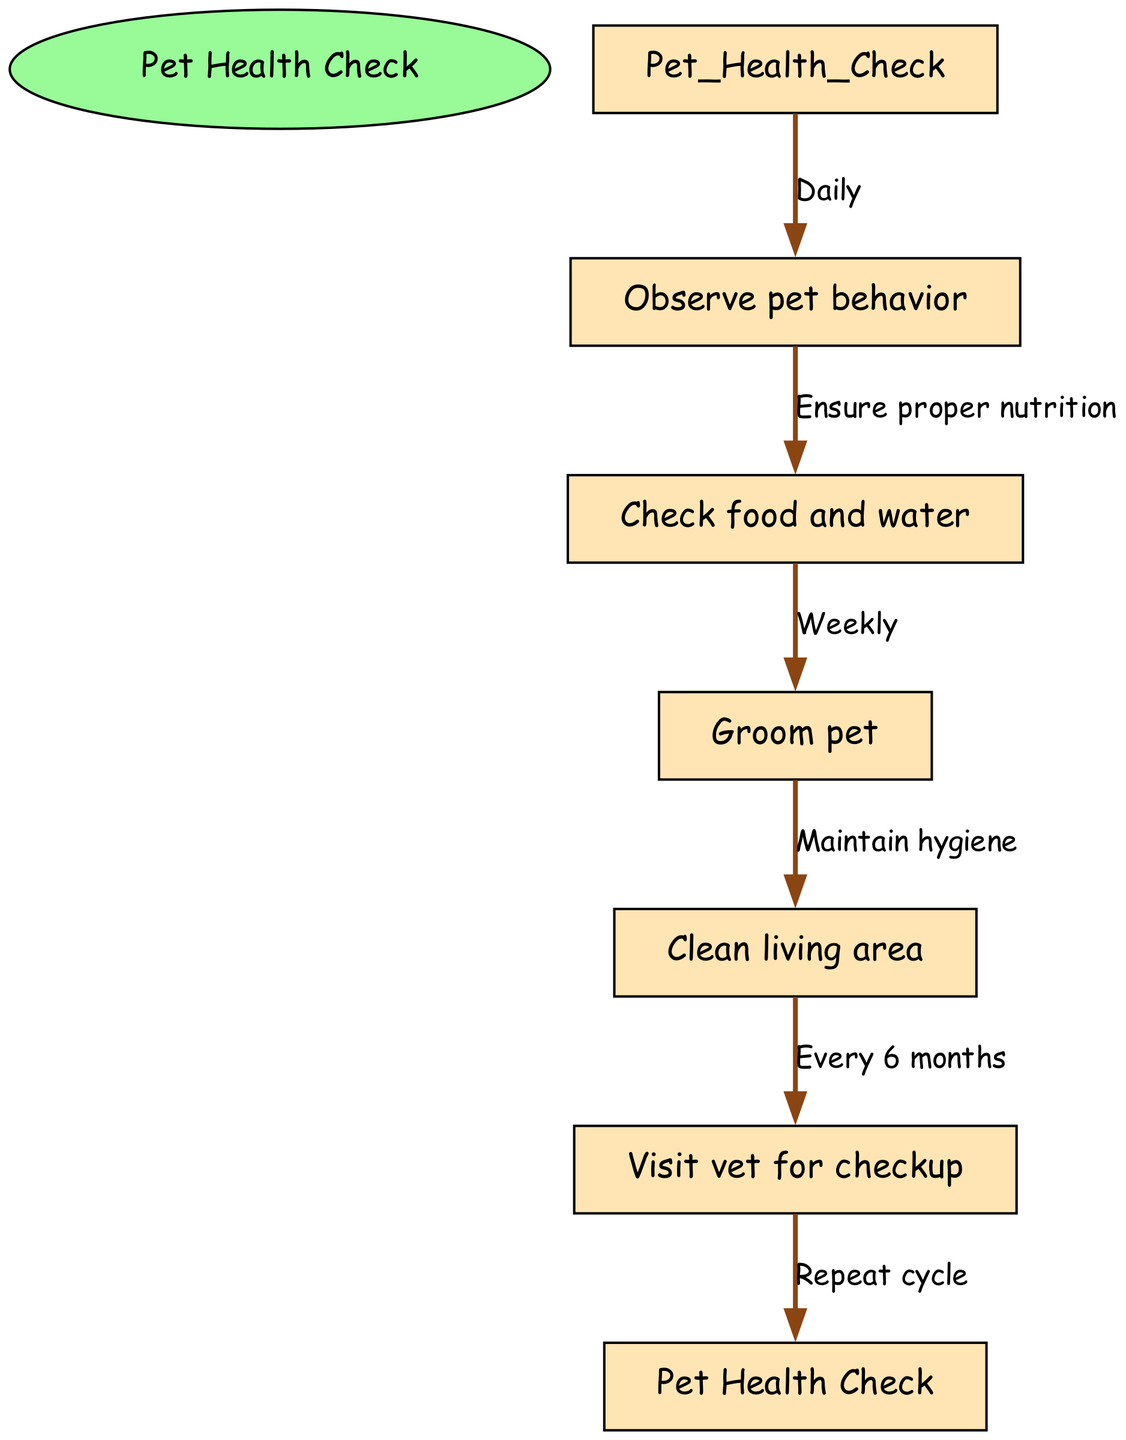What is the first step in the clinical pathway? The first step in the clinical pathway is the "Pet Health Check," which is the start node. It indicates where the assessment process begins.
Answer: Pet Health Check How many nodes are in the diagram? The diagram consists of five nodes, which represent distinct steps in the clinical pathway for addressing pet health.
Answer: 5 What is the relationship between "Observe pet behavior" and "Check food and water"? The relationship is that you observe pet behavior to ensure proper nutrition, connecting the first and second nodes in the pathway.
Answer: Ensure proper nutrition How often should you groom your pet according to the pathway? The diagram states that you should groom your pet weekly as part of maintaining the pet's hygiene.
Answer: Weekly What is the final action in the clinical pathway? The final action described in the clinical pathway is to "Repeat cycle," which indicates that the process is cyclical and should continue indefinitely returning to the initial step.
Answer: Repeat cycle What happens after cleaning the living area? After cleaning the living area, the next step is to visit the vet for a checkup, demonstrating the relationship between hygiene maintenance and veterinary care.
Answer: Visit vet for checkup How often should you visit the vet according to the diagram? The diagram suggests visiting the vet for a checkup every six months, indicating a timeframe for preventative care within the pathway.
Answer: Every 6 months 